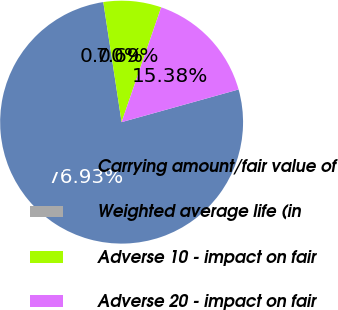Convert chart. <chart><loc_0><loc_0><loc_500><loc_500><pie_chart><fcel>Carrying amount/fair value of<fcel>Weighted average life (in<fcel>Adverse 10 - impact on fair<fcel>Adverse 20 - impact on fair<nl><fcel>76.92%<fcel>0.0%<fcel>7.69%<fcel>15.38%<nl></chart> 